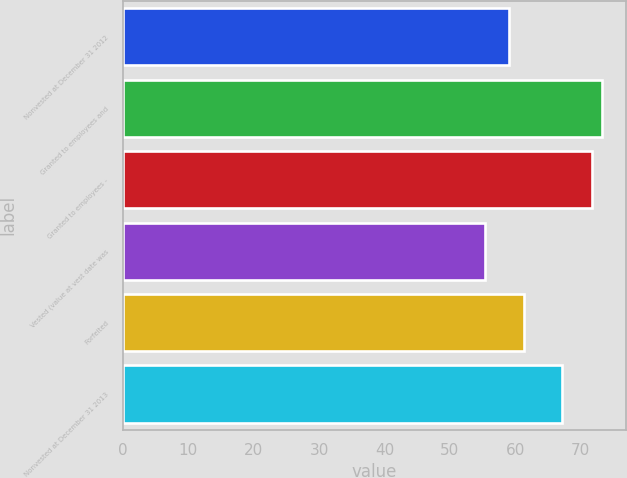<chart> <loc_0><loc_0><loc_500><loc_500><bar_chart><fcel>Nonvested at December 31 2012<fcel>Granted to employees and<fcel>Granted to employees -<fcel>Vested (value at vest date was<fcel>Forfeited<fcel>Nonvested at December 31 2013<nl><fcel>59.13<fcel>73.35<fcel>71.7<fcel>55.35<fcel>61.38<fcel>67.21<nl></chart> 